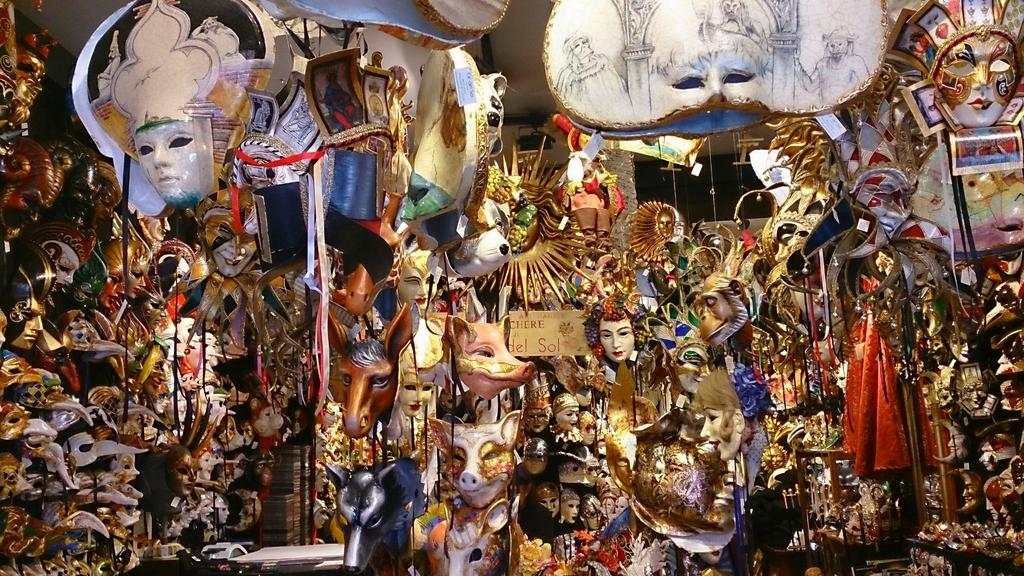What type of protective gear is shown in the image? There are face masks in the image. What can be seen in the background of the image? There is a wall in the background of the image. What type of material is visible in the image? There is a cloth visible in the image. How many clocks are hanging on the wall in the image? There are no clocks visible in the image; only face masks, a wall, and a cloth are present. 